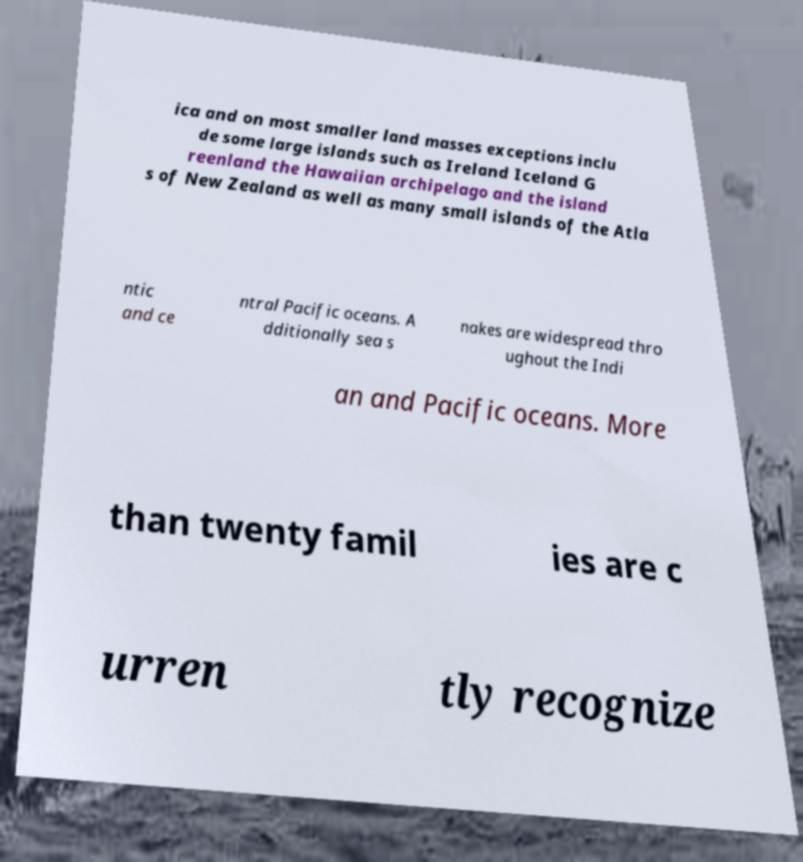I need the written content from this picture converted into text. Can you do that? ica and on most smaller land masses exceptions inclu de some large islands such as Ireland Iceland G reenland the Hawaiian archipelago and the island s of New Zealand as well as many small islands of the Atla ntic and ce ntral Pacific oceans. A dditionally sea s nakes are widespread thro ughout the Indi an and Pacific oceans. More than twenty famil ies are c urren tly recognize 